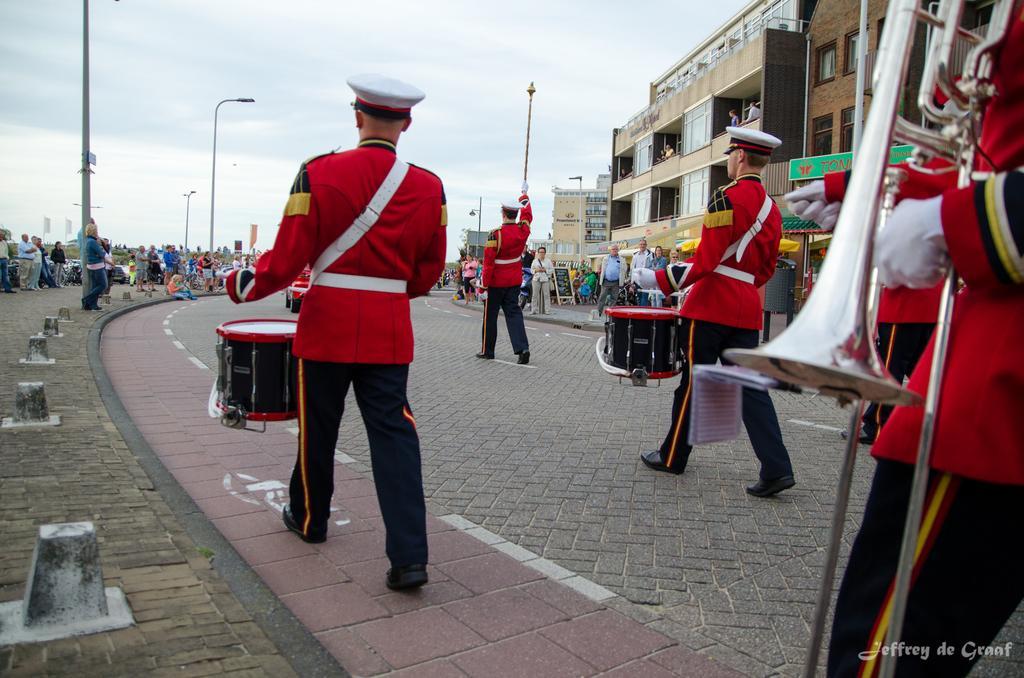Describe this image in one or two sentences. In this image we can see the people playing the drums and also the musical instruments. We can also see the buildings, light poles, barrier rods, path, board and also the road. In the background we can see the people and also the sky. 